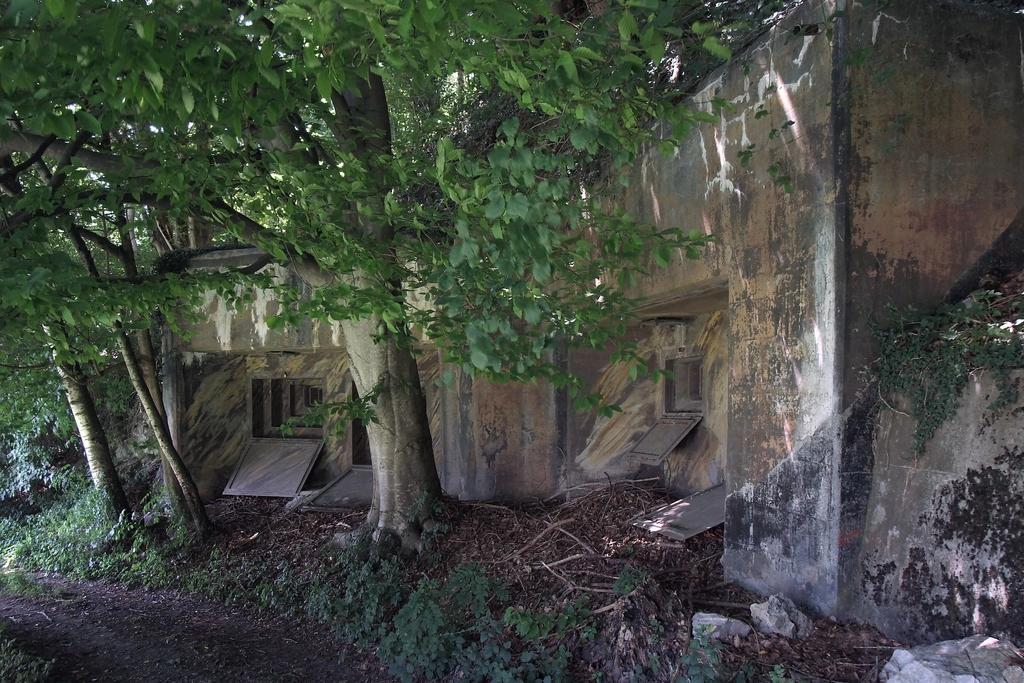What type of natural elements can be seen in the image? There are trees, plants, and rocks visible in the image. What is the surface on which the natural elements are situated? The ground is visible in the image. What type of structure is present in the image? There is a wall with windows in the image. What material is used for some of the objects in the image? There are metal objects in the image. What type of bun is being used to hold the plants in the image? There is no bun present in the image; the plants are not being held by any bun. What type of mint can be seen growing among the rocks in the image? There is no mint visible in the image; only plants and rocks are present. 